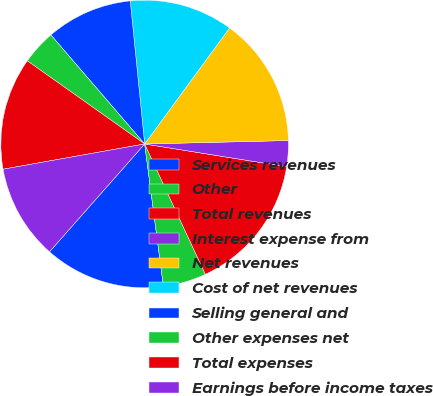<chart> <loc_0><loc_0><loc_500><loc_500><pie_chart><fcel>Services revenues<fcel>Other<fcel>Total revenues<fcel>Interest expense from<fcel>Net revenues<fcel>Cost of net revenues<fcel>Selling general and<fcel>Other expenses net<fcel>Total expenses<fcel>Earnings before income taxes<nl><fcel>13.59%<fcel>4.85%<fcel>15.53%<fcel>2.91%<fcel>14.56%<fcel>11.65%<fcel>9.71%<fcel>3.88%<fcel>12.62%<fcel>10.68%<nl></chart> 